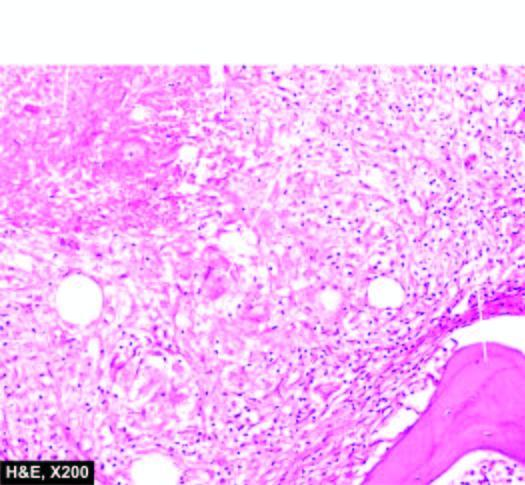re natomical subdivisions of the stomach also seen?
Answer the question using a single word or phrase. No 